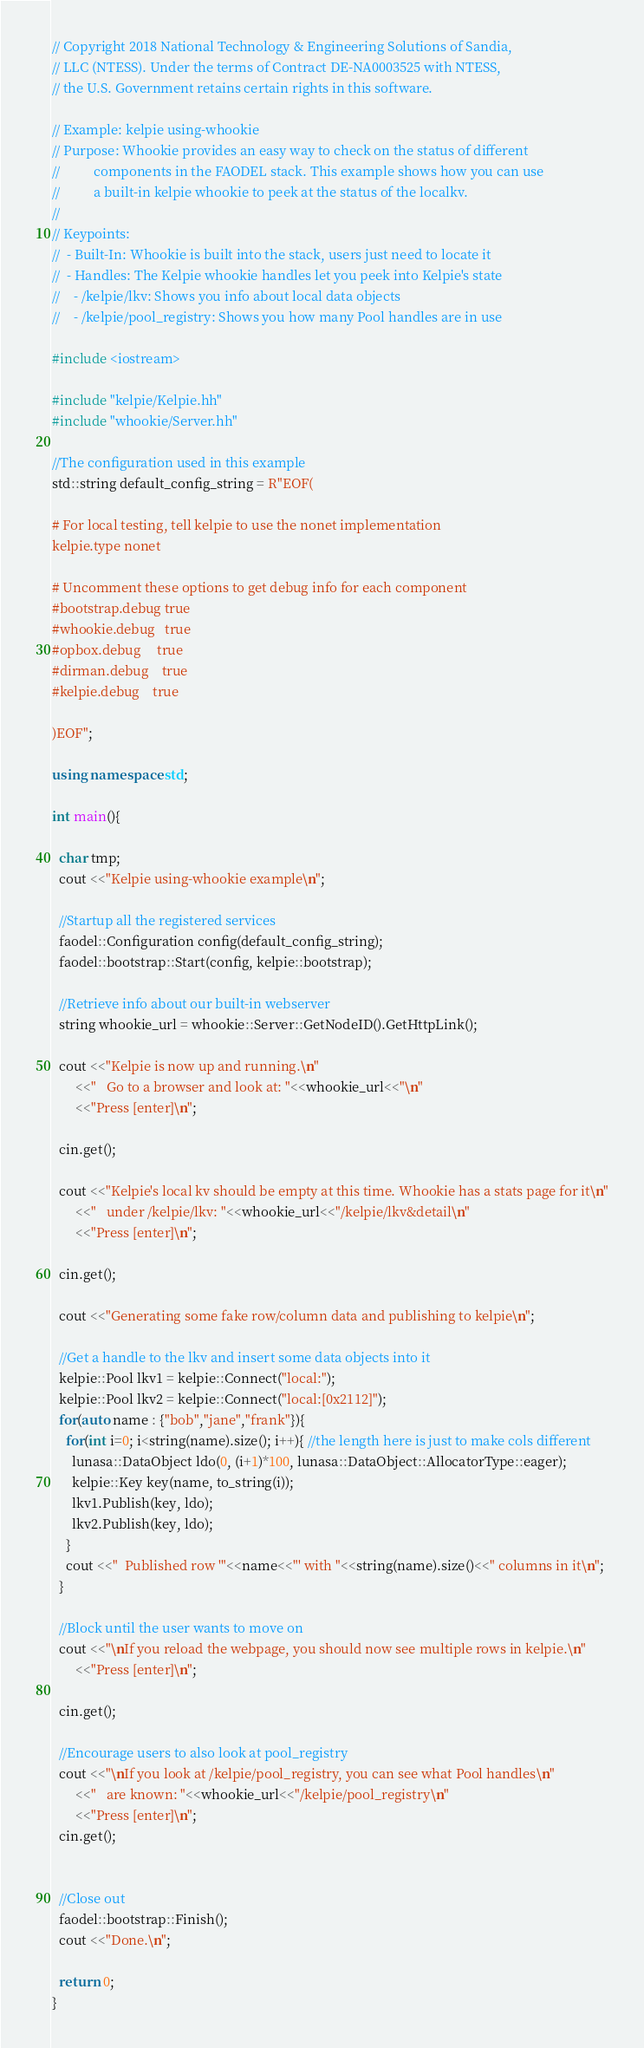<code> <loc_0><loc_0><loc_500><loc_500><_C++_>// Copyright 2018 National Technology & Engineering Solutions of Sandia, 
// LLC (NTESS). Under the terms of Contract DE-NA0003525 with NTESS,  
// the U.S. Government retains certain rights in this software. 

// Example: kelpie using-whookie
// Purpose: Whookie provides an easy way to check on the status of different
//          components in the FAODEL stack. This example shows how you can use
//          a built-in kelpie whookie to peek at the status of the localkv.
//
// Keypoints:
//  - Built-In: Whookie is built into the stack, users just need to locate it
//  - Handles: The Kelpie whookie handles let you peek into Kelpie's state
//    - /kelpie/lkv: Shows you info about local data objects
//    - /kelpie/pool_registry: Shows you how many Pool handles are in use

#include <iostream>

#include "kelpie/Kelpie.hh"
#include "whookie/Server.hh"

//The configuration used in this example
std::string default_config_string = R"EOF(

# For local testing, tell kelpie to use the nonet implementation
kelpie.type nonet

# Uncomment these options to get debug info for each component
#bootstrap.debug true
#whookie.debug   true
#opbox.debug     true
#dirman.debug    true
#kelpie.debug    true

)EOF";

using namespace std;

int main(){

  char tmp;
  cout <<"Kelpie using-whookie example\n";

  //Startup all the registered services
  faodel::Configuration config(default_config_string);
  faodel::bootstrap::Start(config, kelpie::bootstrap);

  //Retrieve info about our built-in webserver
  string whookie_url = whookie::Server::GetNodeID().GetHttpLink();

  cout <<"Kelpie is now up and running.\n"
       <<"   Go to a browser and look at: "<<whookie_url<<"\n"
       <<"Press [enter]\n";

  cin.get();

  cout <<"Kelpie's local kv should be empty at this time. Whookie has a stats page for it\n"
       <<"   under /kelpie/lkv: "<<whookie_url<<"/kelpie/lkv&detail\n"
       <<"Press [enter]\n";

  cin.get();

  cout <<"Generating some fake row/column data and publishing to kelpie\n";

  //Get a handle to the lkv and insert some data objects into it
  kelpie::Pool lkv1 = kelpie::Connect("local:");
  kelpie::Pool lkv2 = kelpie::Connect("local:[0x2112]");
  for(auto name : {"bob","jane","frank"}){
    for(int i=0; i<string(name).size(); i++){ //the length here is just to make cols different
      lunasa::DataObject ldo(0, (i+1)*100, lunasa::DataObject::AllocatorType::eager);
      kelpie::Key key(name, to_string(i));
      lkv1.Publish(key, ldo);
      lkv2.Publish(key, ldo);
    }
    cout <<"  Published row '"<<name<<"' with "<<string(name).size()<<" columns in it\n";
  }

  //Block until the user wants to move on
  cout <<"\nIf you reload the webpage, you should now see multiple rows in kelpie.\n"
       <<"Press [enter]\n";

  cin.get();

  //Encourage users to also look at pool_registry
  cout <<"\nIf you look at /kelpie/pool_registry, you can see what Pool handles\n"
       <<"   are known: "<<whookie_url<<"/kelpie/pool_registry\n"
       <<"Press [enter]\n";
  cin.get();


  //Close out
  faodel::bootstrap::Finish();
  cout <<"Done.\n";

  return 0;
}
</code> 